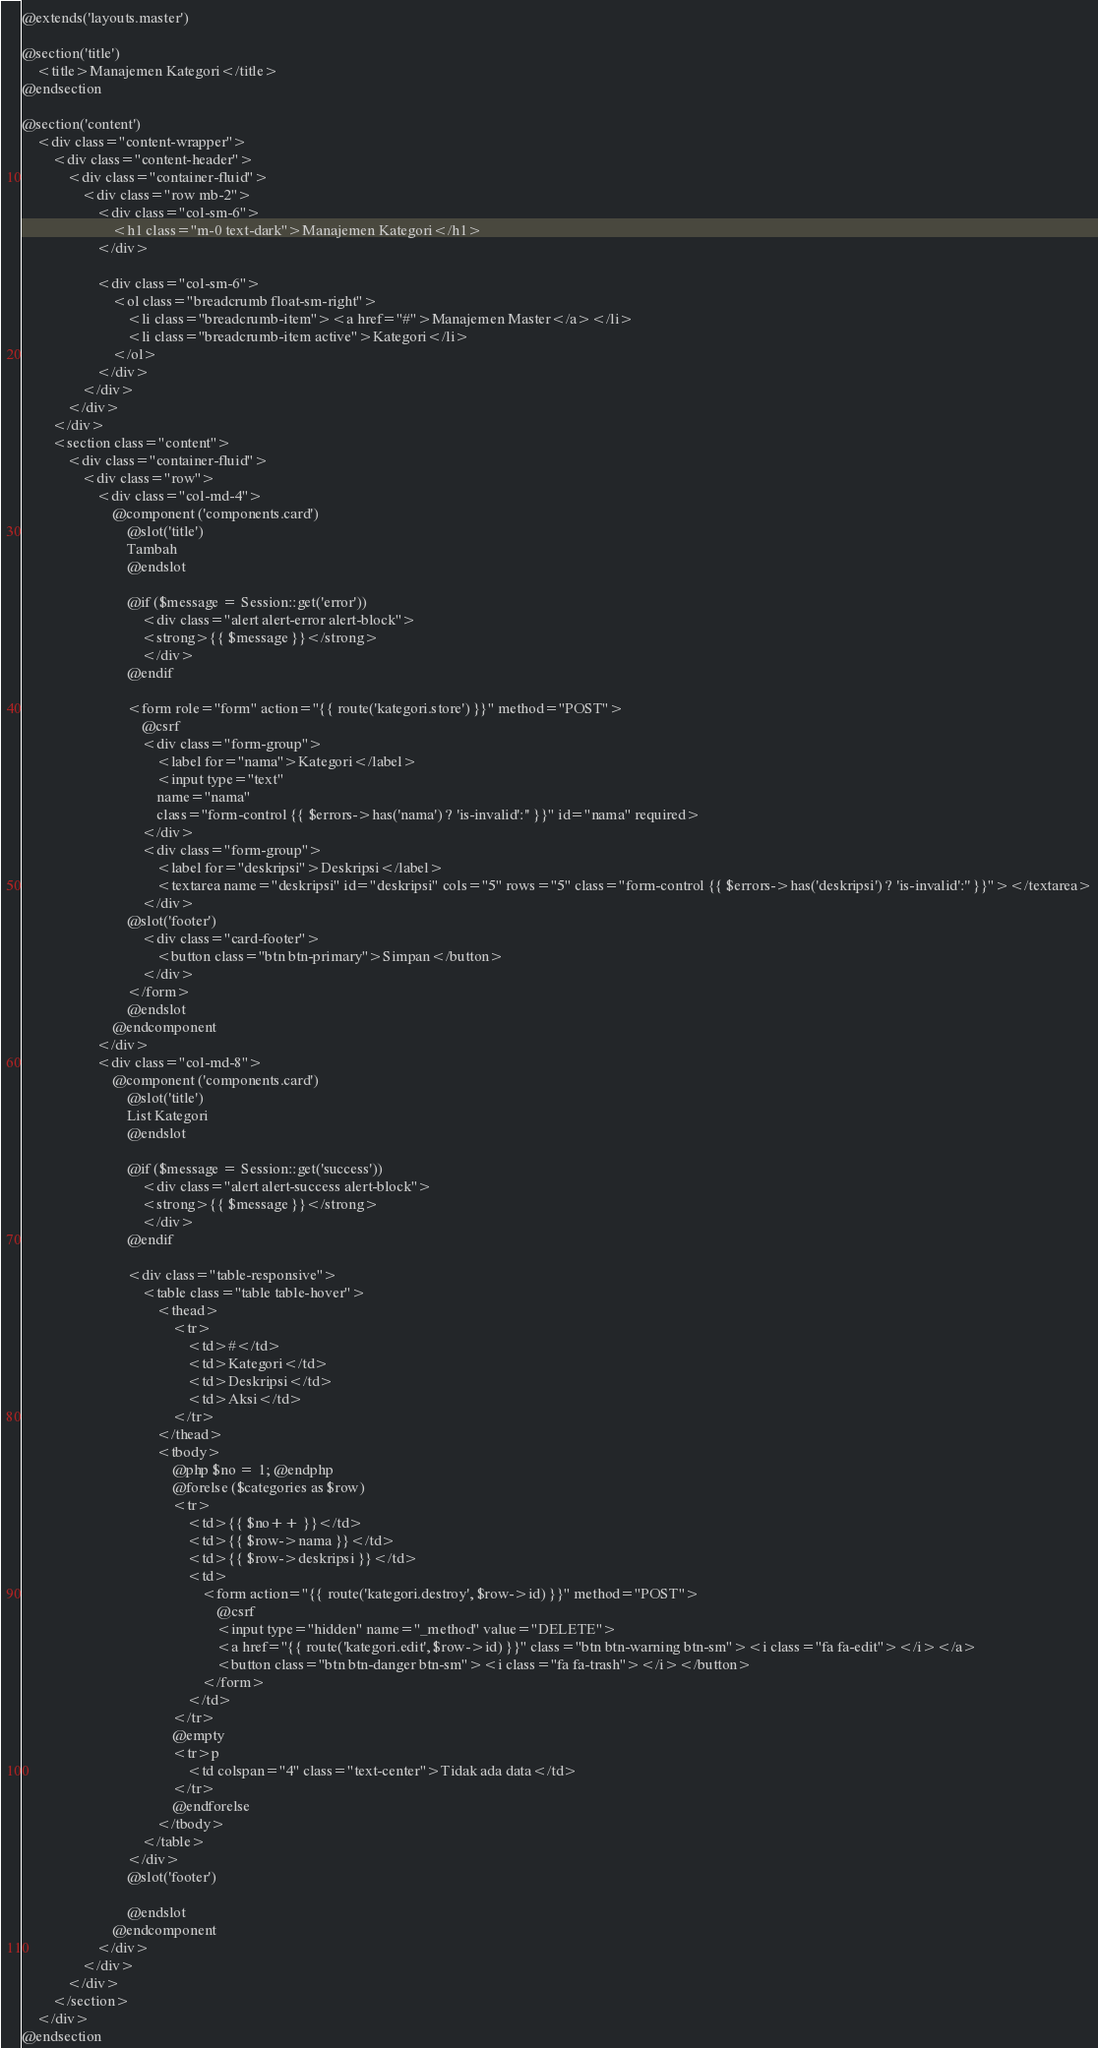<code> <loc_0><loc_0><loc_500><loc_500><_PHP_>@extends('layouts.master')

@section('title')
    <title>Manajemen Kategori</title>
@endsection

@section('content')
    <div class="content-wrapper">
        <div class="content-header">
            <div class="container-fluid">
                <div class="row mb-2">
                    <div class="col-sm-6">
                        <h1 class="m-0 text-dark">Manajemen Kategori</h1>
                    </div>
                    
                    <div class="col-sm-6">
                        <ol class="breadcrumb float-sm-right">
                            <li class="breadcrumb-item"><a href="#">Manajemen Master</a></li>
                            <li class="breadcrumb-item active">Kategori</li>
                        </ol>
                    </div>
                </div>
            </div>
        </div>
        <section class="content">
            <div class="container-fluid">
                <div class="row">
                    <div class="col-md-4">
                        @component ('components.card')
                            @slot('title')
                            Tambah
                            @endslot
                            
                            @if ($message = Session::get('error'))
				                <div class="alert alert-error alert-block">
					            <strong>{{ $message }}</strong>
				                </div>
			            	@endif

                            <form role="form" action="{{ route('kategori.store') }}" method="POST">
                                @csrf
                                <div class="form-group">
                                    <label for="nama">Kategori</label>
                                    <input type="text" 
                                    name="nama"
                                    class="form-control {{ $errors->has('nama') ? 'is-invalid':'' }}" id="nama" required>
                                </div>
                                <div class="form-group">
                                    <label for="deskripsi">Deskripsi</label>
                                    <textarea name="deskripsi" id="deskripsi" cols="5" rows="5" class="form-control {{ $errors->has('deskripsi') ? 'is-invalid':'' }}"></textarea>
                                </div>
                            @slot('footer')
                                <div class="card-footer">
                                    <button class="btn btn-primary">Simpan</button>
                                </div>
                            </form>
                            @endslot
                        @endcomponent
                    </div>
                    <div class="col-md-8">
                        @component ('components.card')
                            @slot('title')
                            List Kategori
                            @endslot
                            
                            @if ($message = Session::get('success'))
				                <div class="alert alert-success alert-block">
					            <strong>{{ $message }}</strong>
				                </div>
			            	@endif
                            
                            <div class="table-responsive">
                                <table class="table table-hover">
                                    <thead>
                                        <tr>
                                            <td>#</td>
                                            <td>Kategori</td>
                                            <td>Deskripsi</td>
                                            <td>Aksi</td>
                                        </tr>
                                    </thead>
                                    <tbody>
                                        @php $no = 1; @endphp
                                        @forelse ($categories as $row)
                                        <tr>
                                            <td>{{ $no++ }}</td>
                                            <td>{{ $row->nama }}</td>
                                            <td>{{ $row->deskripsi }}</td>
                                            <td>
                                                <form action="{{ route('kategori.destroy', $row->id) }}" method="POST">
                                                    @csrf
                                                    <input type="hidden" name="_method" value="DELETE">
                                                    <a href="{{ route('kategori.edit', $row->id) }}" class="btn btn-warning btn-sm"><i class="fa fa-edit"></i></a>
                                                    <button class="btn btn-danger btn-sm"><i class="fa fa-trash"></i></button>
                                                </form>
                                            </td>
                                        </tr>
                                        @empty
                                        <tr>p
                                            <td colspan="4" class="text-center">Tidak ada data</td>
                                        </tr>
                                        @endforelse
                                    </tbody>
                                </table>
                            </div>
                            @slot('footer')

                            @endslot
                        @endcomponent
                    </div>
                </div>
            </div>
        </section>
    </div>
@endsection</code> 